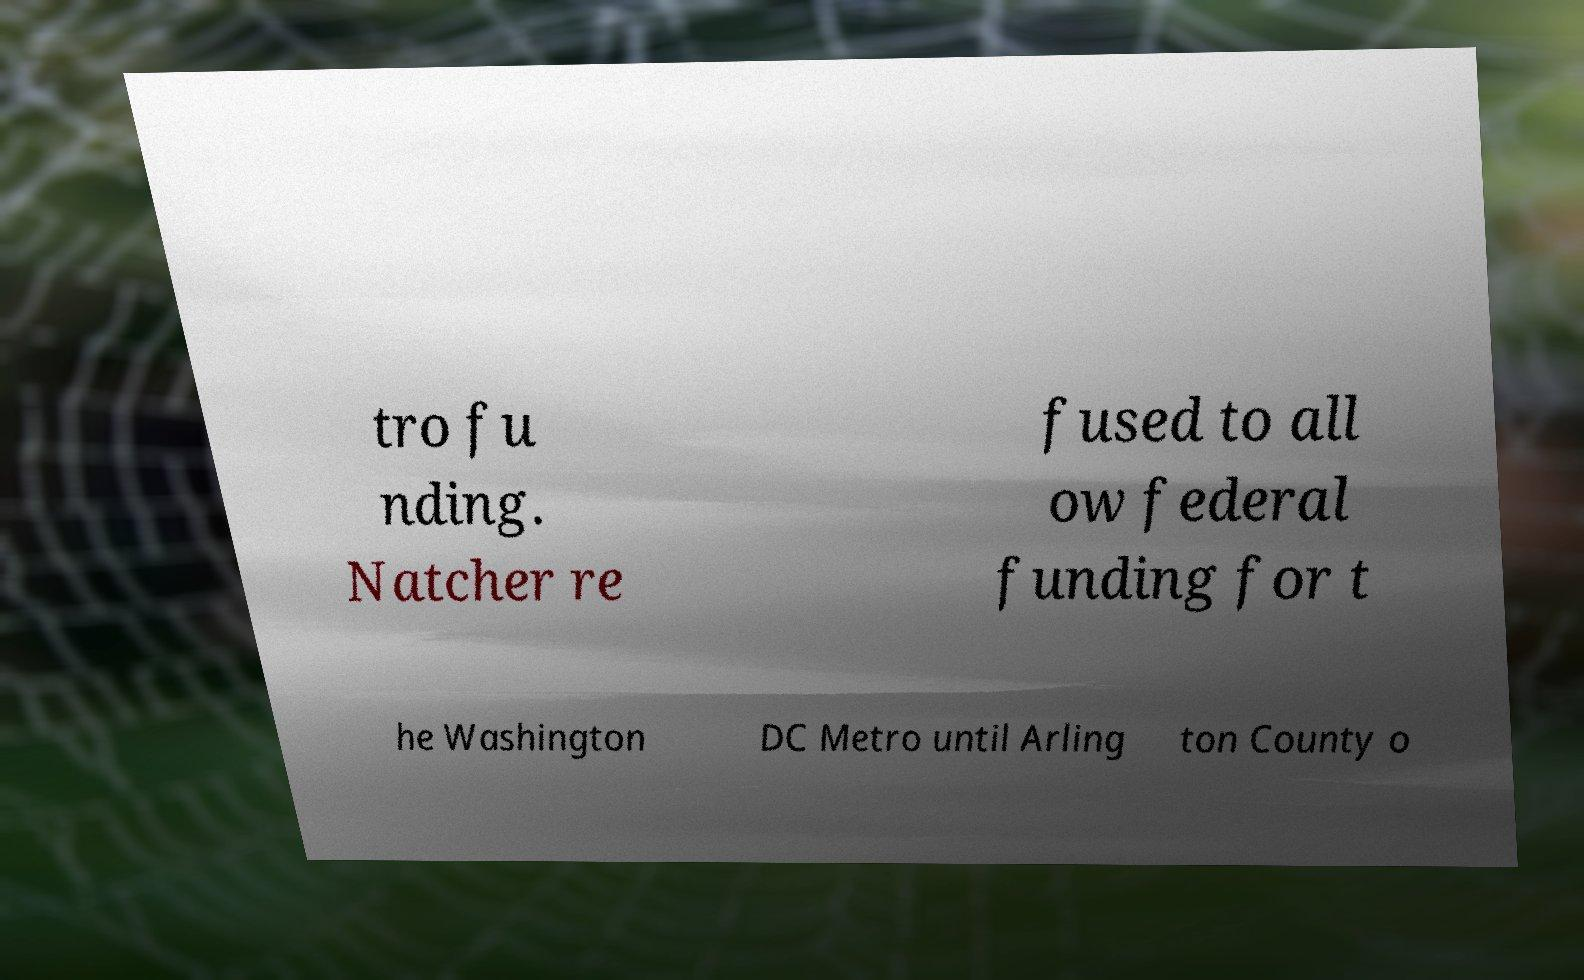I need the written content from this picture converted into text. Can you do that? tro fu nding. Natcher re fused to all ow federal funding for t he Washington DC Metro until Arling ton County o 